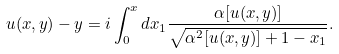<formula> <loc_0><loc_0><loc_500><loc_500>u ( x , y ) - y = i \int ^ { x } _ { 0 } d x _ { 1 } \frac { \alpha [ u ( x , y ) ] } { \sqrt { \alpha ^ { 2 } [ u ( x , y ) ] + 1 - x _ { 1 } } } .</formula> 